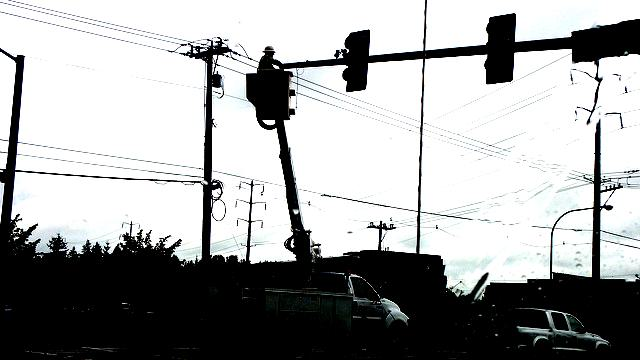Describe the mood or atmosphere conveyed by the image. The image imparts a moody and somber atmosphere. The high contrast and silhouetted objects against the overcast sky suggest an early morning or late evening setting, which often evokes a sense of quietness and introspection. The absence of vibrant colors contributes to a rather solemn and contemplative mood. 